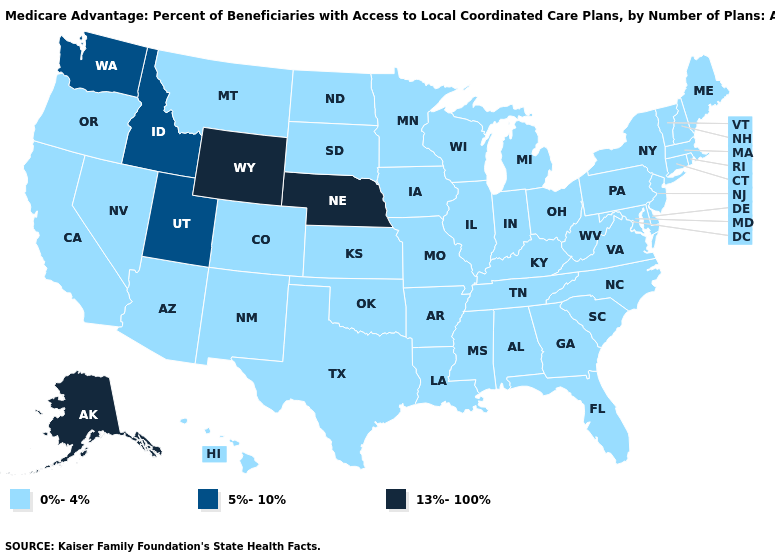Does Nebraska have the highest value in the USA?
Answer briefly. Yes. Name the states that have a value in the range 0%-4%?
Concise answer only. California, Colorado, Connecticut, Delaware, Florida, Georgia, Hawaii, Iowa, Illinois, Indiana, Kansas, Kentucky, Louisiana, Massachusetts, Maryland, Maine, Michigan, Minnesota, Missouri, Mississippi, Montana, North Carolina, North Dakota, New Hampshire, New Jersey, New Mexico, Nevada, New York, Ohio, Oklahoma, Oregon, Pennsylvania, Rhode Island, South Carolina, South Dakota, Tennessee, Texas, Virginia, Vermont, Wisconsin, West Virginia, Alabama, Arkansas, Arizona. What is the value of Pennsylvania?
Be succinct. 0%-4%. Does the first symbol in the legend represent the smallest category?
Be succinct. Yes. Among the states that border Massachusetts , which have the lowest value?
Keep it brief. Connecticut, New Hampshire, New York, Rhode Island, Vermont. What is the value of Alabama?
Concise answer only. 0%-4%. Which states have the lowest value in the USA?
Keep it brief. California, Colorado, Connecticut, Delaware, Florida, Georgia, Hawaii, Iowa, Illinois, Indiana, Kansas, Kentucky, Louisiana, Massachusetts, Maryland, Maine, Michigan, Minnesota, Missouri, Mississippi, Montana, North Carolina, North Dakota, New Hampshire, New Jersey, New Mexico, Nevada, New York, Ohio, Oklahoma, Oregon, Pennsylvania, Rhode Island, South Carolina, South Dakota, Tennessee, Texas, Virginia, Vermont, Wisconsin, West Virginia, Alabama, Arkansas, Arizona. Name the states that have a value in the range 13%-100%?
Answer briefly. Nebraska, Alaska, Wyoming. Does Oklahoma have the lowest value in the USA?
Concise answer only. Yes. Which states have the lowest value in the USA?
Keep it brief. California, Colorado, Connecticut, Delaware, Florida, Georgia, Hawaii, Iowa, Illinois, Indiana, Kansas, Kentucky, Louisiana, Massachusetts, Maryland, Maine, Michigan, Minnesota, Missouri, Mississippi, Montana, North Carolina, North Dakota, New Hampshire, New Jersey, New Mexico, Nevada, New York, Ohio, Oklahoma, Oregon, Pennsylvania, Rhode Island, South Carolina, South Dakota, Tennessee, Texas, Virginia, Vermont, Wisconsin, West Virginia, Alabama, Arkansas, Arizona. What is the value of Alaska?
Quick response, please. 13%-100%. Name the states that have a value in the range 0%-4%?
Quick response, please. California, Colorado, Connecticut, Delaware, Florida, Georgia, Hawaii, Iowa, Illinois, Indiana, Kansas, Kentucky, Louisiana, Massachusetts, Maryland, Maine, Michigan, Minnesota, Missouri, Mississippi, Montana, North Carolina, North Dakota, New Hampshire, New Jersey, New Mexico, Nevada, New York, Ohio, Oklahoma, Oregon, Pennsylvania, Rhode Island, South Carolina, South Dakota, Tennessee, Texas, Virginia, Vermont, Wisconsin, West Virginia, Alabama, Arkansas, Arizona. What is the value of Connecticut?
Short answer required. 0%-4%. Does South Dakota have the highest value in the MidWest?
Quick response, please. No. What is the value of Arkansas?
Be succinct. 0%-4%. 